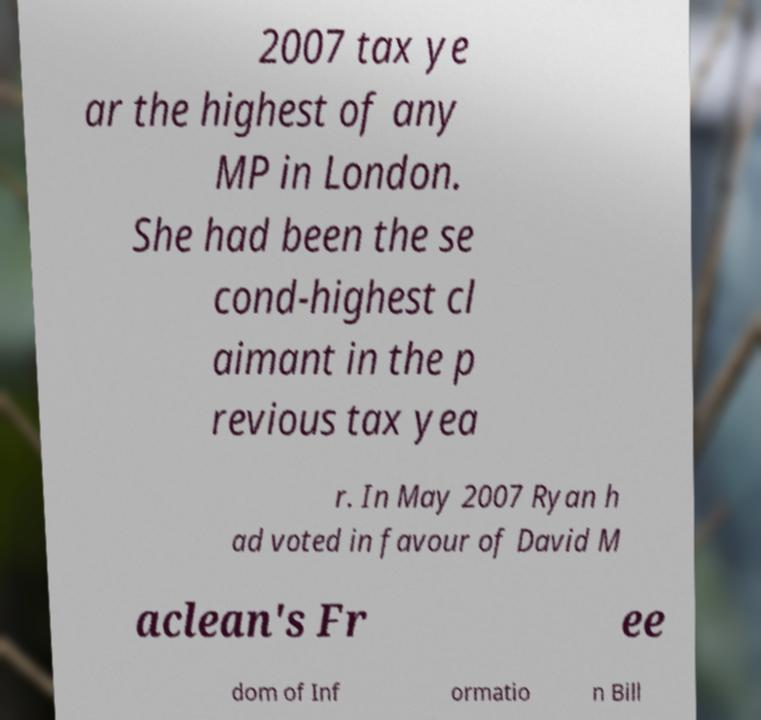What messages or text are displayed in this image? I need them in a readable, typed format. 2007 tax ye ar the highest of any MP in London. She had been the se cond-highest cl aimant in the p revious tax yea r. In May 2007 Ryan h ad voted in favour of David M aclean's Fr ee dom of Inf ormatio n Bill 